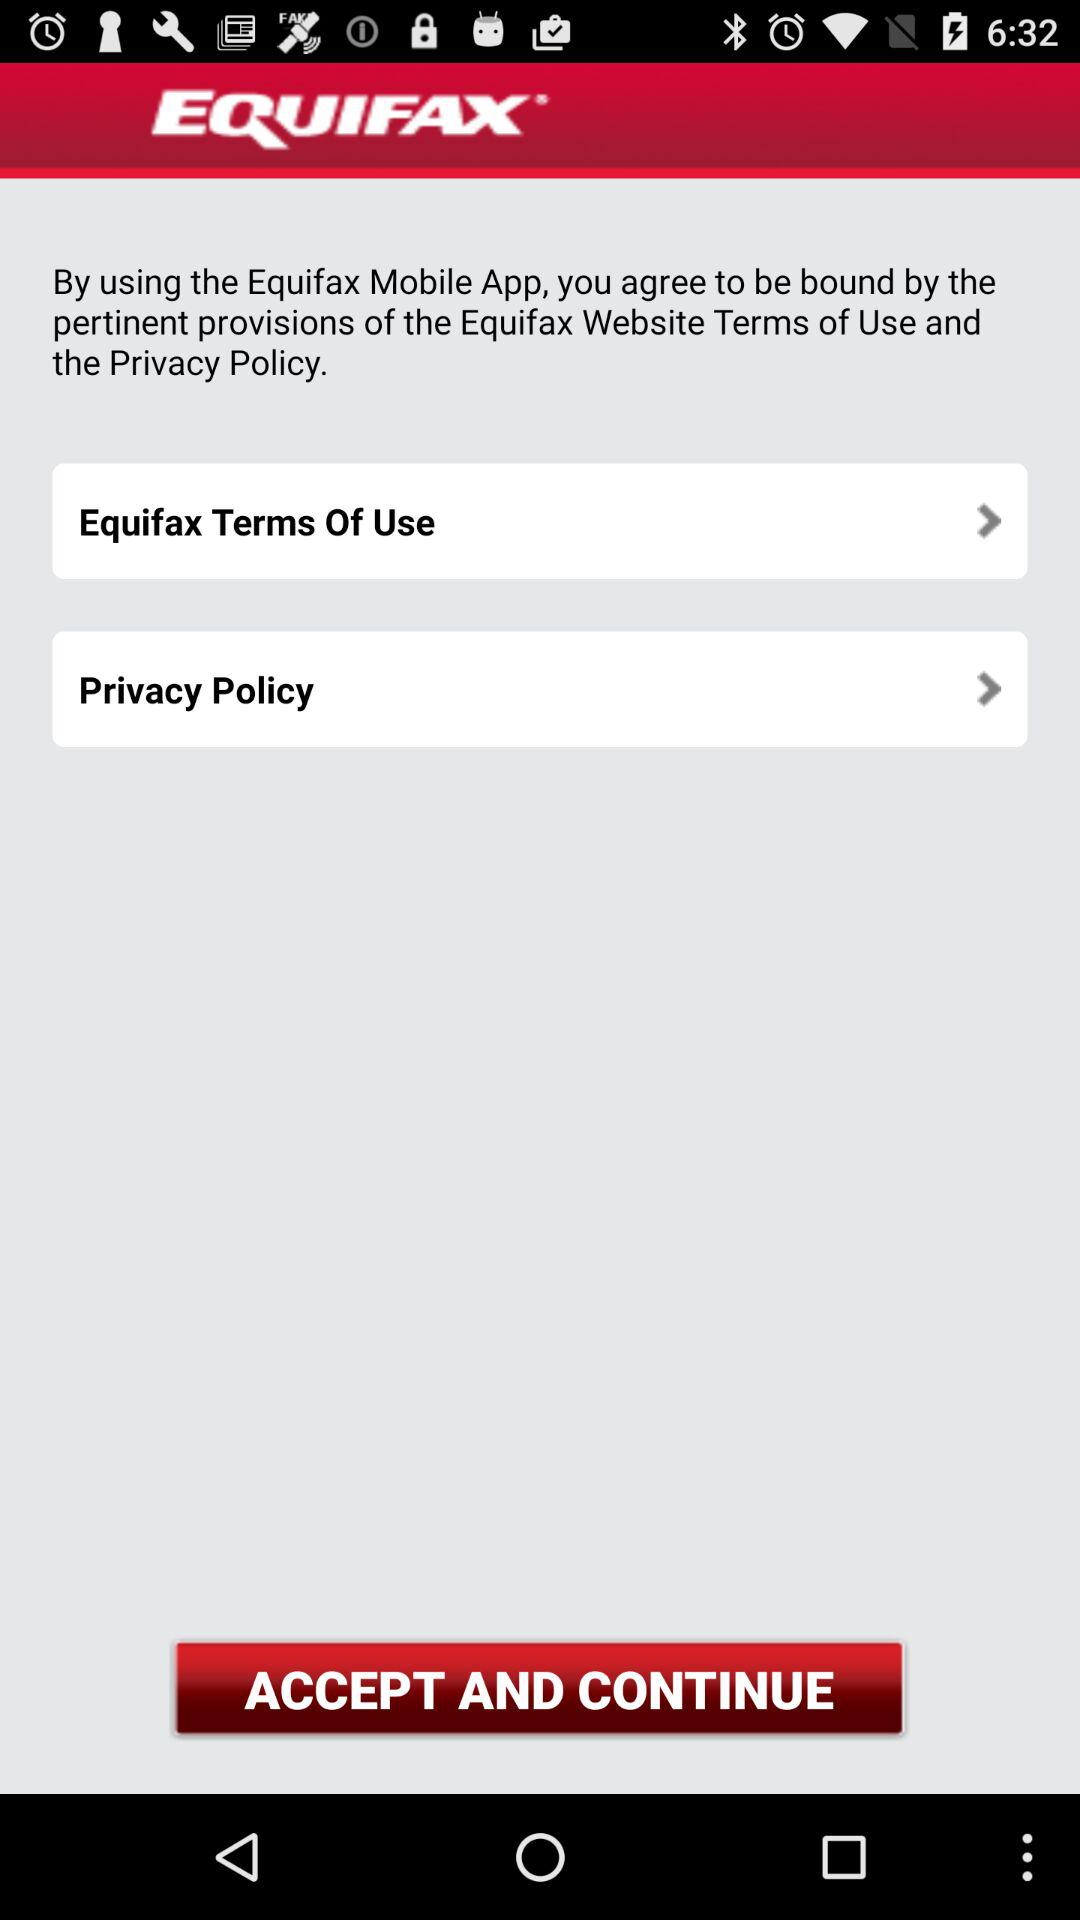How many more terms of use links are there than privacy policy links?
Answer the question using a single word or phrase. 1 